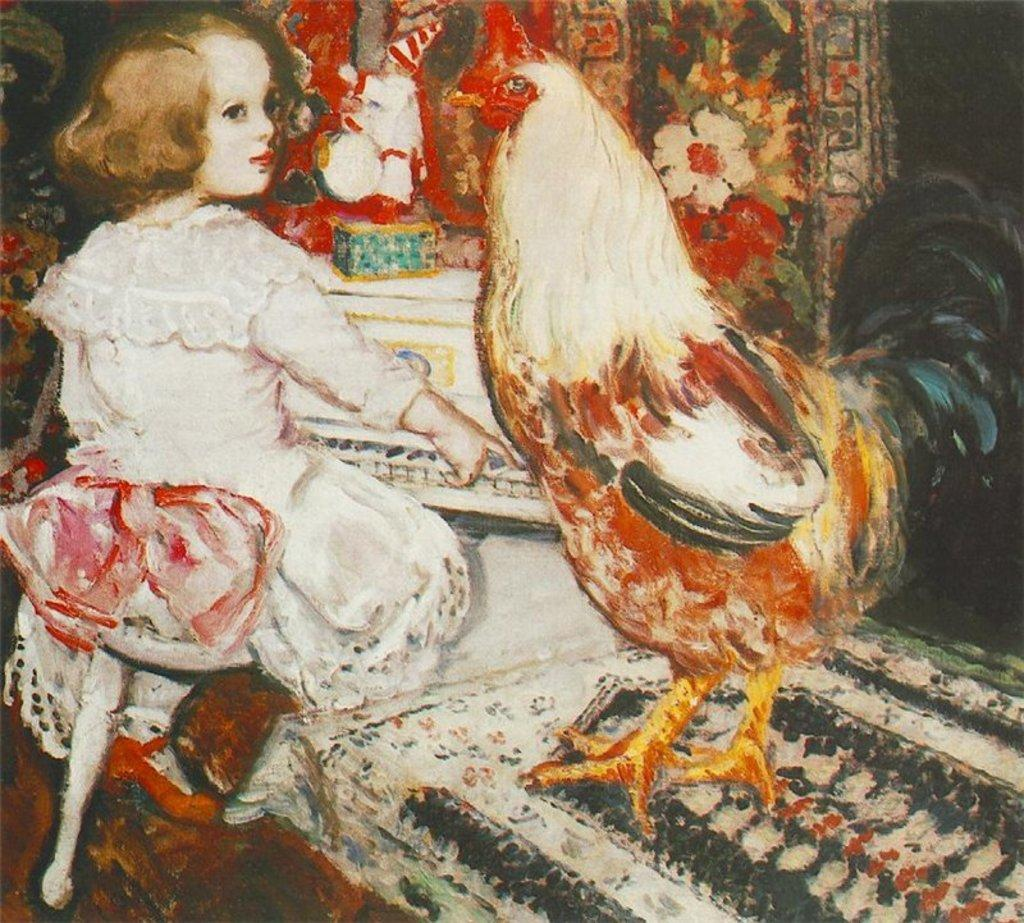What is the main subject of the image? The image contains a painting. What is the girl in the painting doing? The girl is sitting on a chair in the painting. What is near the girl in the painting? The girl is near a table in the painting. What is on the table in the painting? There is a cock standing on the table in the painting. What can be seen in the background of the painting? The background of the painting includes flowers and a table. What type of thread is being used by the girl in the painting? There is no thread present in the painting; the girl is sitting on a chair and there is a cock on the table. 